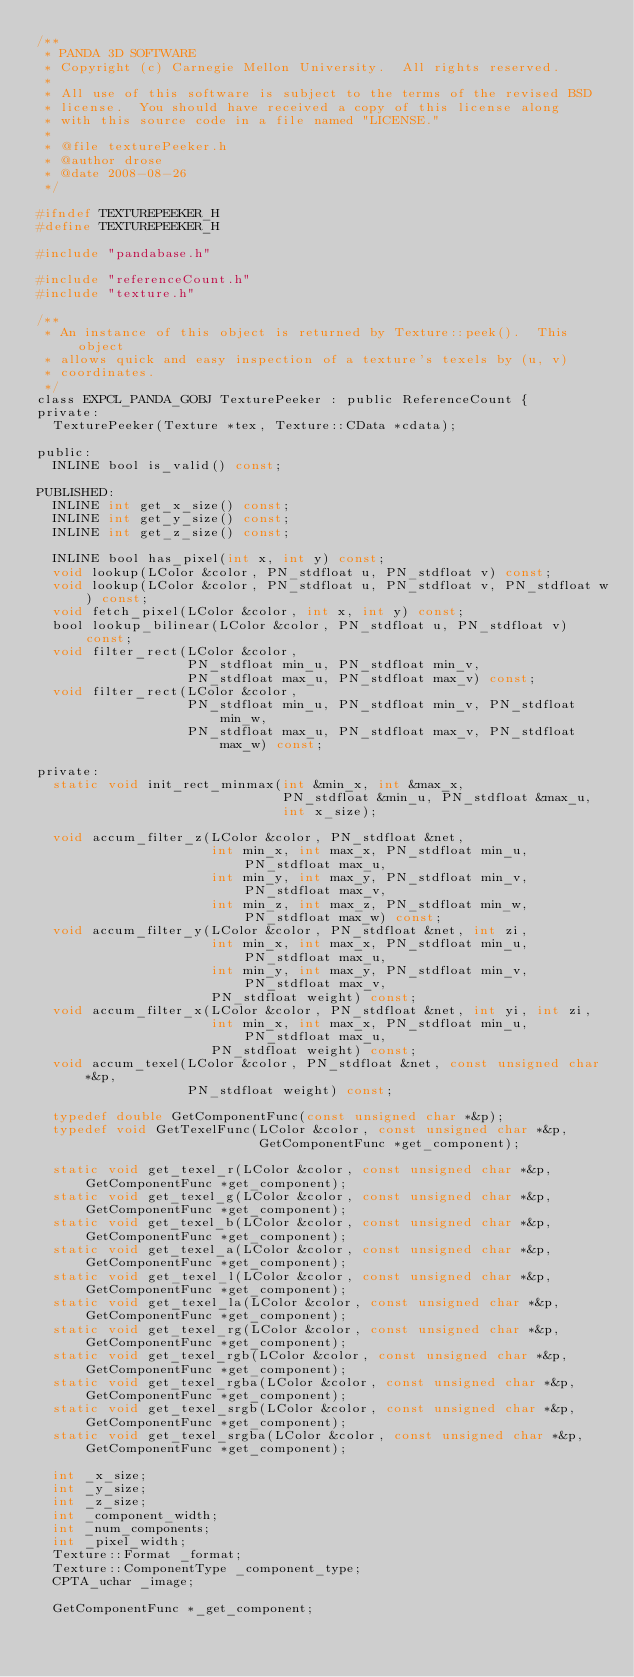Convert code to text. <code><loc_0><loc_0><loc_500><loc_500><_C_>/**
 * PANDA 3D SOFTWARE
 * Copyright (c) Carnegie Mellon University.  All rights reserved.
 *
 * All use of this software is subject to the terms of the revised BSD
 * license.  You should have received a copy of this license along
 * with this source code in a file named "LICENSE."
 *
 * @file texturePeeker.h
 * @author drose
 * @date 2008-08-26
 */

#ifndef TEXTUREPEEKER_H
#define TEXTUREPEEKER_H

#include "pandabase.h"

#include "referenceCount.h"
#include "texture.h"

/**
 * An instance of this object is returned by Texture::peek().  This object
 * allows quick and easy inspection of a texture's texels by (u, v)
 * coordinates.
 */
class EXPCL_PANDA_GOBJ TexturePeeker : public ReferenceCount {
private:
  TexturePeeker(Texture *tex, Texture::CData *cdata);

public:
  INLINE bool is_valid() const;

PUBLISHED:
  INLINE int get_x_size() const;
  INLINE int get_y_size() const;
  INLINE int get_z_size() const;

  INLINE bool has_pixel(int x, int y) const;
  void lookup(LColor &color, PN_stdfloat u, PN_stdfloat v) const;
  void lookup(LColor &color, PN_stdfloat u, PN_stdfloat v, PN_stdfloat w) const;
  void fetch_pixel(LColor &color, int x, int y) const;
  bool lookup_bilinear(LColor &color, PN_stdfloat u, PN_stdfloat v) const;
  void filter_rect(LColor &color,
                   PN_stdfloat min_u, PN_stdfloat min_v,
                   PN_stdfloat max_u, PN_stdfloat max_v) const;
  void filter_rect(LColor &color,
                   PN_stdfloat min_u, PN_stdfloat min_v, PN_stdfloat min_w,
                   PN_stdfloat max_u, PN_stdfloat max_v, PN_stdfloat max_w) const;

private:
  static void init_rect_minmax(int &min_x, int &max_x,
                               PN_stdfloat &min_u, PN_stdfloat &max_u,
                               int x_size);

  void accum_filter_z(LColor &color, PN_stdfloat &net,
                      int min_x, int max_x, PN_stdfloat min_u, PN_stdfloat max_u,
                      int min_y, int max_y, PN_stdfloat min_v, PN_stdfloat max_v,
                      int min_z, int max_z, PN_stdfloat min_w, PN_stdfloat max_w) const;
  void accum_filter_y(LColor &color, PN_stdfloat &net, int zi,
                      int min_x, int max_x, PN_stdfloat min_u, PN_stdfloat max_u,
                      int min_y, int max_y, PN_stdfloat min_v, PN_stdfloat max_v,
                      PN_stdfloat weight) const;
  void accum_filter_x(LColor &color, PN_stdfloat &net, int yi, int zi,
                      int min_x, int max_x, PN_stdfloat min_u, PN_stdfloat max_u,
                      PN_stdfloat weight) const;
  void accum_texel(LColor &color, PN_stdfloat &net, const unsigned char *&p,
                   PN_stdfloat weight) const;

  typedef double GetComponentFunc(const unsigned char *&p);
  typedef void GetTexelFunc(LColor &color, const unsigned char *&p,
                            GetComponentFunc *get_component);

  static void get_texel_r(LColor &color, const unsigned char *&p, GetComponentFunc *get_component);
  static void get_texel_g(LColor &color, const unsigned char *&p, GetComponentFunc *get_component);
  static void get_texel_b(LColor &color, const unsigned char *&p, GetComponentFunc *get_component);
  static void get_texel_a(LColor &color, const unsigned char *&p, GetComponentFunc *get_component);
  static void get_texel_l(LColor &color, const unsigned char *&p, GetComponentFunc *get_component);
  static void get_texel_la(LColor &color, const unsigned char *&p, GetComponentFunc *get_component);
  static void get_texel_rg(LColor &color, const unsigned char *&p, GetComponentFunc *get_component);
  static void get_texel_rgb(LColor &color, const unsigned char *&p, GetComponentFunc *get_component);
  static void get_texel_rgba(LColor &color, const unsigned char *&p, GetComponentFunc *get_component);
  static void get_texel_srgb(LColor &color, const unsigned char *&p, GetComponentFunc *get_component);
  static void get_texel_srgba(LColor &color, const unsigned char *&p, GetComponentFunc *get_component);

  int _x_size;
  int _y_size;
  int _z_size;
  int _component_width;
  int _num_components;
  int _pixel_width;
  Texture::Format _format;
  Texture::ComponentType _component_type;
  CPTA_uchar _image;

  GetComponentFunc *_get_component;</code> 